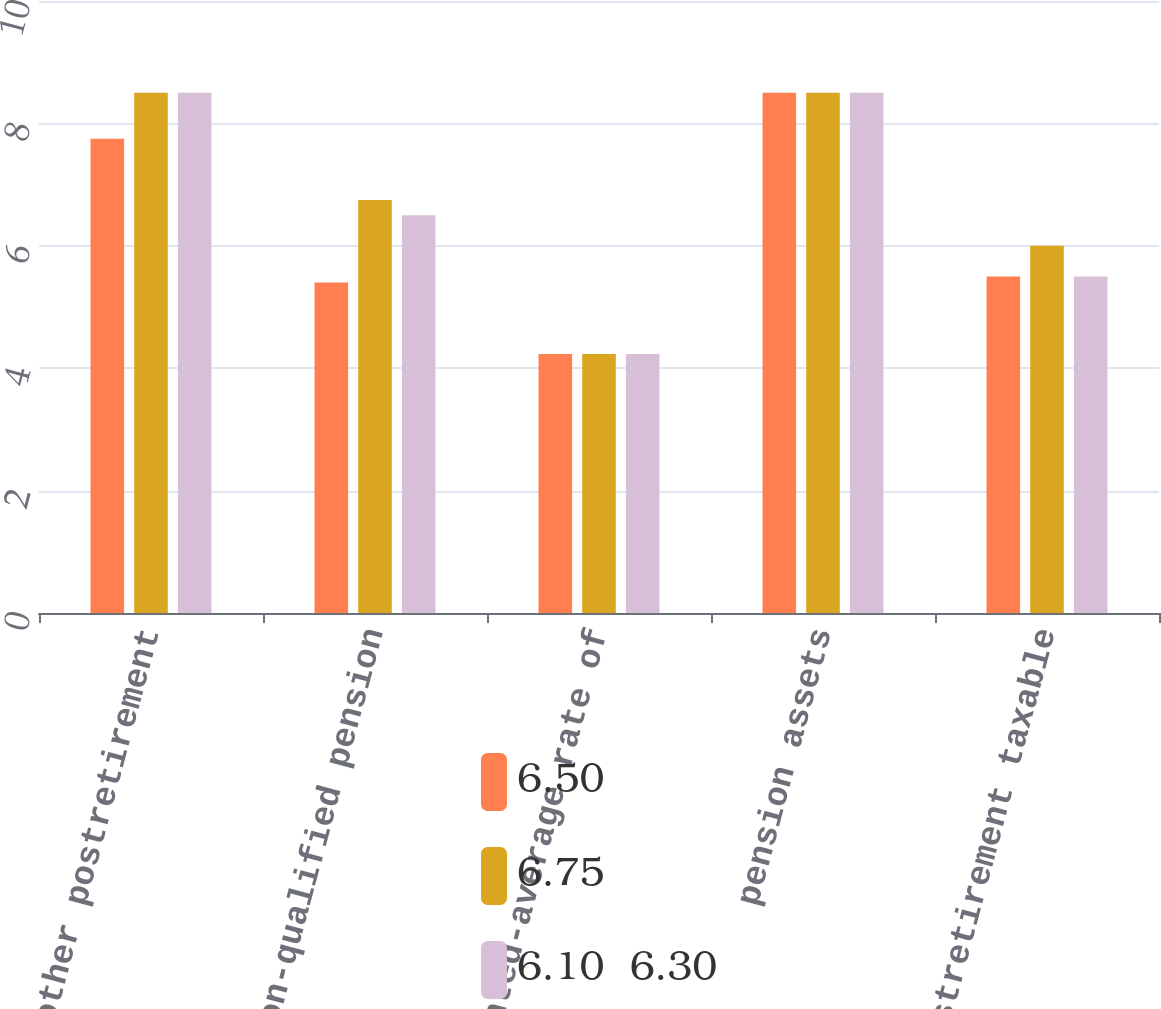Convert chart to OTSL. <chart><loc_0><loc_0><loc_500><loc_500><stacked_bar_chart><ecel><fcel>other postretirement<fcel>non-qualified pension<fcel>Weighted-average rate of<fcel>pension assets<fcel>other postretirement taxable<nl><fcel>6.50<fcel>7.75<fcel>5.4<fcel>4.23<fcel>8.5<fcel>5.5<nl><fcel>6.75<fcel>8.5<fcel>6.75<fcel>4.23<fcel>8.5<fcel>6<nl><fcel>6.10  6.30<fcel>8.5<fcel>6.5<fcel>4.23<fcel>8.5<fcel>5.5<nl></chart> 